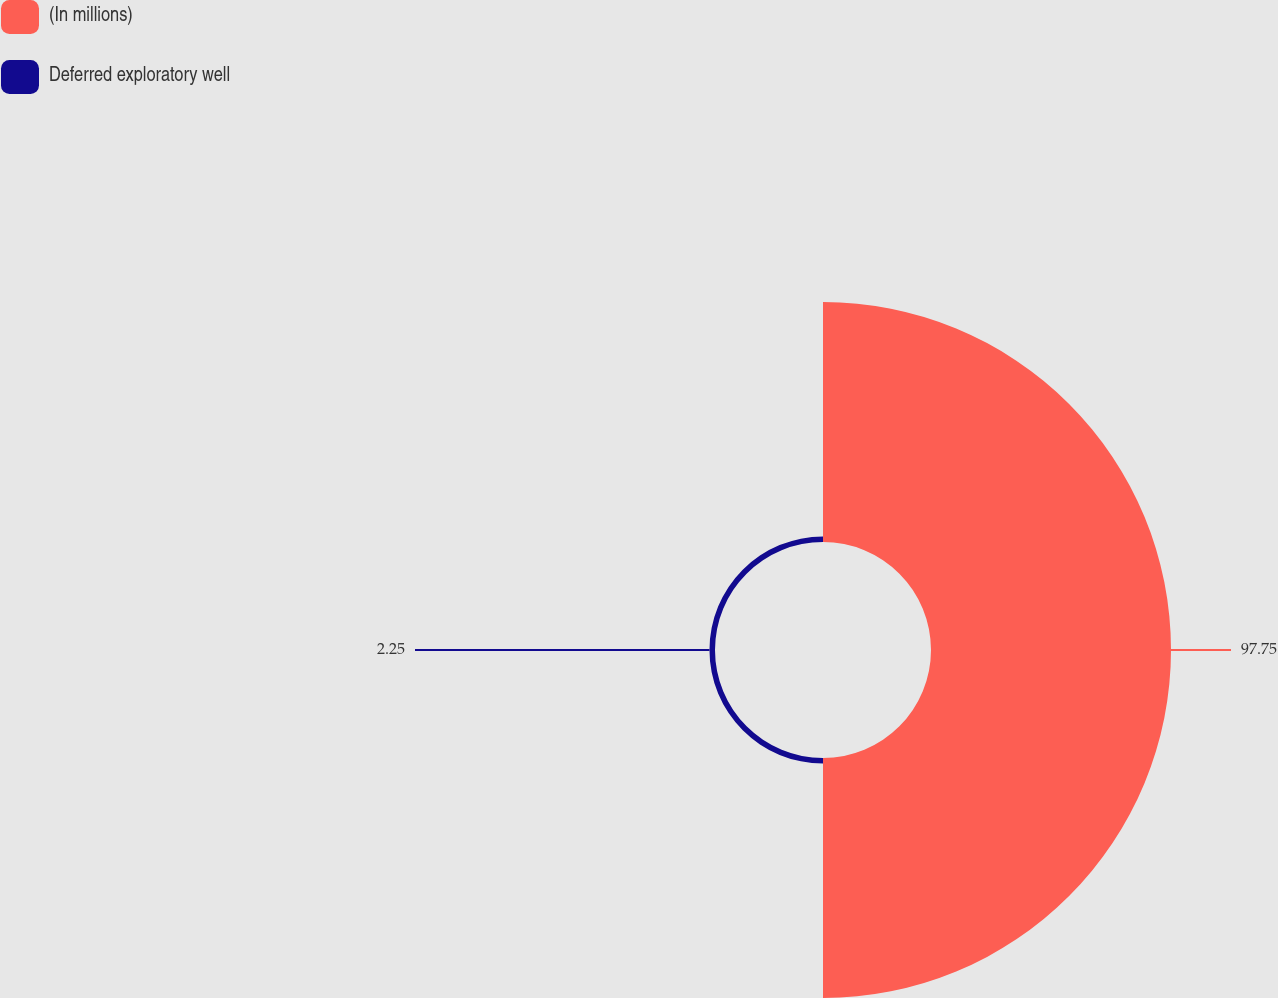Convert chart to OTSL. <chart><loc_0><loc_0><loc_500><loc_500><pie_chart><fcel>(In millions)<fcel>Deferred exploratory well<nl><fcel>97.75%<fcel>2.25%<nl></chart> 